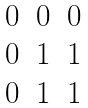Convert formula to latex. <formula><loc_0><loc_0><loc_500><loc_500>\begin{matrix} 0 & 0 & 0 \\ 0 & 1 & 1 \\ 0 & 1 & 1 \end{matrix}</formula> 